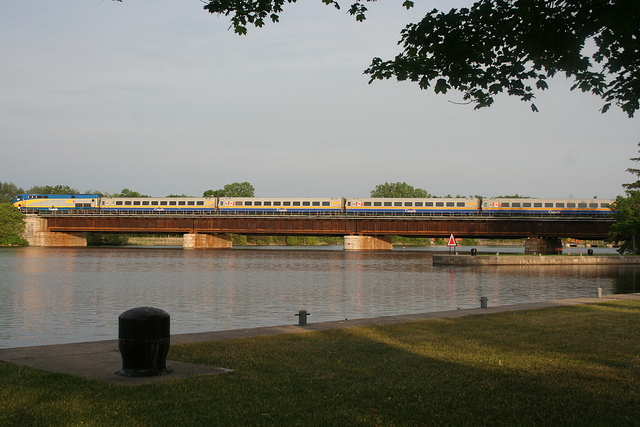<image>What color is the fire hydrant? I don't know what color the fire hydrant is, it's either red or black or it may not be visible in the image. What color is the fire hydrant? There is no fire hydrant in the image. 